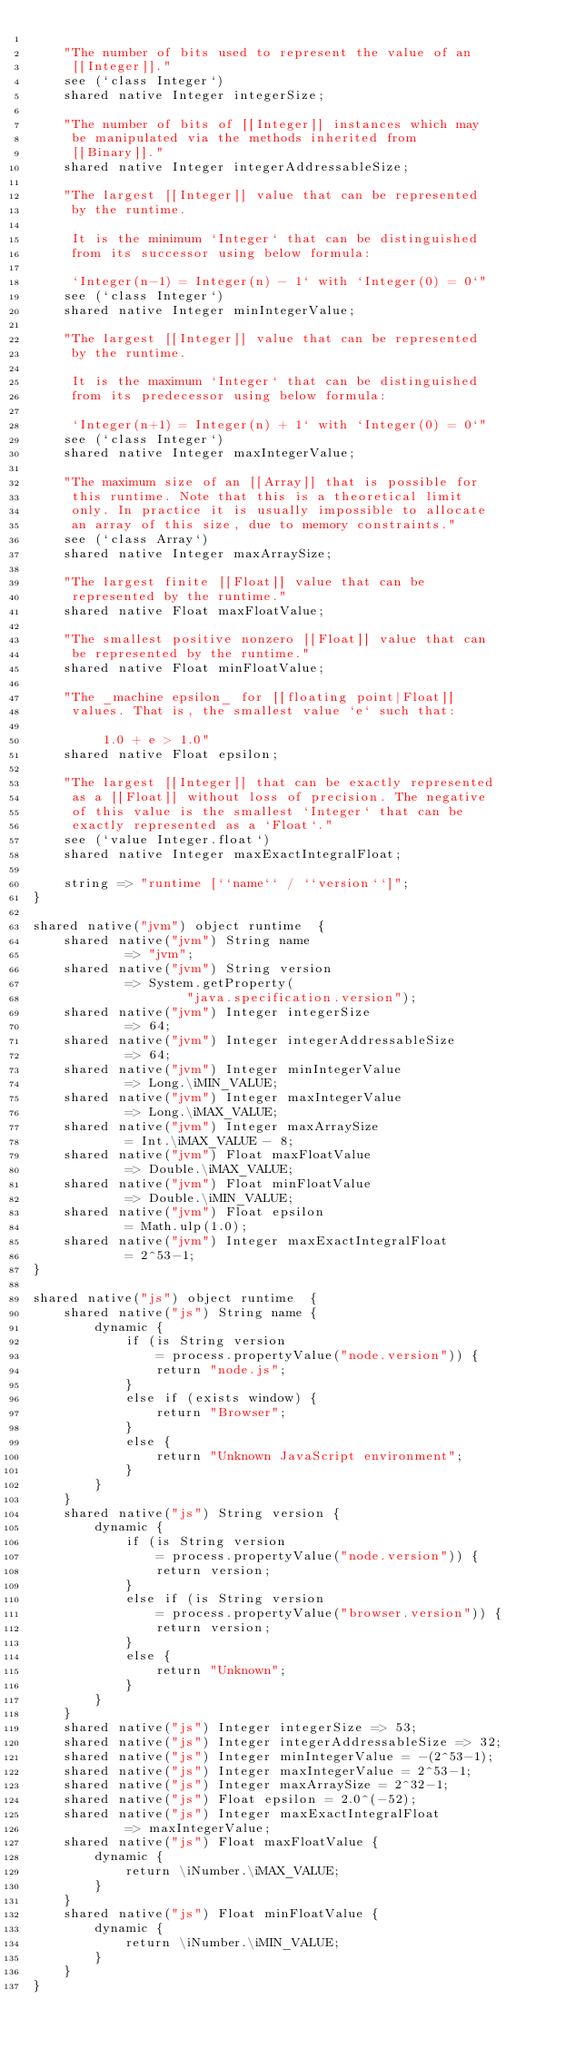Convert code to text. <code><loc_0><loc_0><loc_500><loc_500><_Ceylon_>    
    "The number of bits used to represent the value of an 
     [[Integer]]."
    see (`class Integer`)
    shared native Integer integerSize;
    
    "The number of bits of [[Integer]] instances which may 
     be manipulated via the methods inherited from
     [[Binary]]."
    shared native Integer integerAddressableSize;
    
    "The largest [[Integer]] value that can be represented 
     by the runtime.
     
     It is the minimum `Integer` that can be distinguished 
     from its successor using below formula:
     
     `Integer(n-1) = Integer(n) - 1` with `Integer(0) = 0`"
    see (`class Integer`)
    shared native Integer minIntegerValue;

    "The largest [[Integer]] value that can be represented 
     by the runtime.
     
     It is the maximum `Integer` that can be distinguished 
     from its predecessor using below formula:
     
     `Integer(n+1) = Integer(n) + 1` with `Integer(0) = 0`"
    see (`class Integer`)
    shared native Integer maxIntegerValue;
    
    "The maximum size of an [[Array]] that is possible for 
     this runtime. Note that this is a theoretical limit 
     only. In practice it is usually impossible to allocate 
     an array of this size, due to memory constraints."
    see (`class Array`)
    shared native Integer maxArraySize;
    
    "The largest finite [[Float]] value that can be 
     represented by the runtime."
    shared native Float maxFloatValue;

    "The smallest positive nonzero [[Float]] value that can 
     be represented by the runtime."
    shared native Float minFloatValue;
    
    "The _machine epsilon_ for [[floating point|Float]]
     values. That is, the smallest value `e` such that:
     
         1.0 + e > 1.0"
    shared native Float epsilon; 
    
    "The largest [[Integer]] that can be exactly represented
     as a [[Float]] without loss of precision. The negative
     of this value is the smallest `Integer` that can be
     exactly represented as a `Float`."
    see (`value Integer.float`)
    shared native Integer maxExactIntegralFloat;
    
    string => "runtime [``name`` / ``version``]";
}

shared native("jvm") object runtime  {
    shared native("jvm") String name 
            => "jvm";
    shared native("jvm") String version 
            => System.getProperty(
                    "java.specification.version");
    shared native("jvm") Integer integerSize 
            => 64;
    shared native("jvm") Integer integerAddressableSize 
            => 64;
    shared native("jvm") Integer minIntegerValue 
            => Long.\iMIN_VALUE;
    shared native("jvm") Integer maxIntegerValue 
            => Long.\iMAX_VALUE;
    shared native("jvm") Integer maxArraySize 
            = Int.\iMAX_VALUE - 8;
    shared native("jvm") Float maxFloatValue 
            => Double.\iMAX_VALUE;
    shared native("jvm") Float minFloatValue 
            => Double.\iMIN_VALUE;    
    shared native("jvm") Float epsilon 
            = Math.ulp(1.0);
    shared native("jvm") Integer maxExactIntegralFloat 
            = 2^53-1;
}

shared native("js") object runtime  {
    shared native("js") String name {
        dynamic {
            if (is String version 
                = process.propertyValue("node.version")) {
                return "node.js";
            }
            else if (exists window) {
                return "Browser";
            }
            else {
                return "Unknown JavaScript environment";
            }
        }
    }
    shared native("js") String version {
        dynamic { 
            if (is String version 
                = process.propertyValue("node.version")) {
                return version;
            }
            else if (is String version 
                = process.propertyValue("browser.version")) {
                return version;
            }
            else {
                return "Unknown";
            }
        }
    }
    shared native("js") Integer integerSize => 53;
    shared native("js") Integer integerAddressableSize => 32;
    shared native("js") Integer minIntegerValue = -(2^53-1);
    shared native("js") Integer maxIntegerValue = 2^53-1;
    shared native("js") Integer maxArraySize = 2^32-1;
    shared native("js") Float epsilon = 2.0^(-52);
    shared native("js") Integer maxExactIntegralFloat 
            => maxIntegerValue;
    shared native("js") Float maxFloatValue {
        dynamic {
            return \iNumber.\iMAX_VALUE;
        }
    }
    shared native("js") Float minFloatValue {
        dynamic {
            return \iNumber.\iMIN_VALUE;
        }
    }
}
</code> 